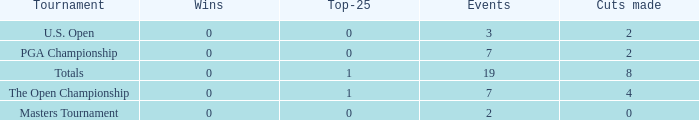What is the lowest Top-25 that has 3 Events and Wins greater than 0? None. 